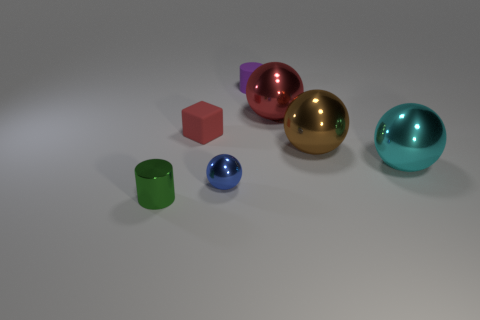Are there fewer red metal things than small yellow metal things?
Keep it short and to the point. No. There is a small object that is both behind the tiny blue object and in front of the small matte cylinder; what is its material?
Give a very brief answer. Rubber. Is there a tiny cylinder that is in front of the metal ball in front of the cyan ball?
Give a very brief answer. Yes. How many large things are the same color as the matte block?
Your answer should be very brief. 1. What is the material of the big sphere that is the same color as the block?
Your response must be concise. Metal. Do the purple cylinder and the small blue sphere have the same material?
Offer a very short reply. No. Are there any blue metallic objects behind the tiny red thing?
Ensure brevity in your answer.  No. What is the material of the big brown sphere to the right of the metallic ball in front of the big cyan metal object?
Offer a terse response. Metal. The green object that is the same shape as the small purple matte object is what size?
Offer a very short reply. Small. Do the small block and the tiny shiny cylinder have the same color?
Keep it short and to the point. No. 